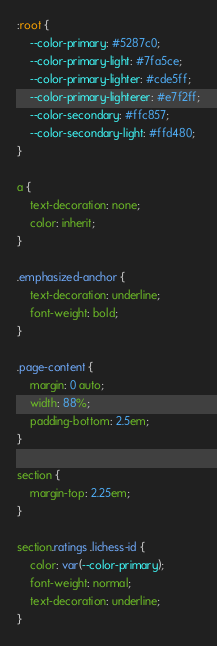Convert code to text. <code><loc_0><loc_0><loc_500><loc_500><_CSS_>:root {
    --color-primary: #5287c0;
    --color-primary-light: #7fa5ce;
    --color-primary-lighter: #cde5ff;
    --color-primary-lighterer: #e7f2ff;
    --color-secondary: #ffc857;
    --color-secondary-light: #ffd480;
}

a {
    text-decoration: none;
    color: inherit;
}

.emphasized-anchor {
    text-decoration: underline;
    font-weight: bold;
}

.page-content {
    margin: 0 auto;
    width: 88%;
    padding-bottom: 2.5em;
}

section {
    margin-top: 2.25em;
}

section.ratings .lichess-id {
    color: var(--color-primary);
    font-weight: normal;
    text-decoration: underline;
}
</code> 